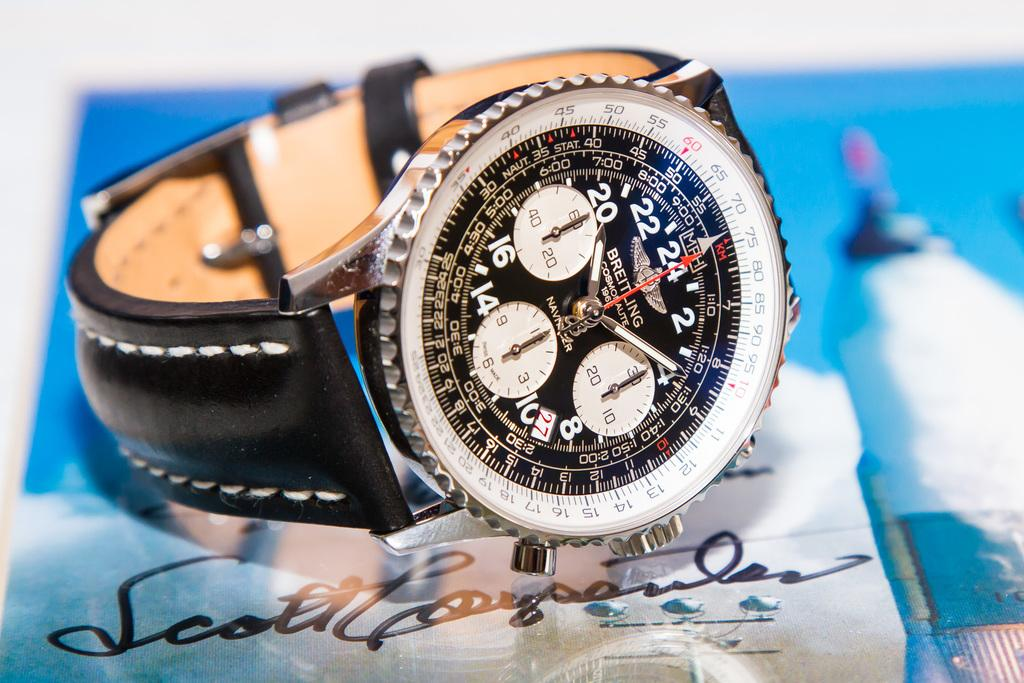<image>
Provide a brief description of the given image. A Breitling brand watch sits on top of a signed photograph. 